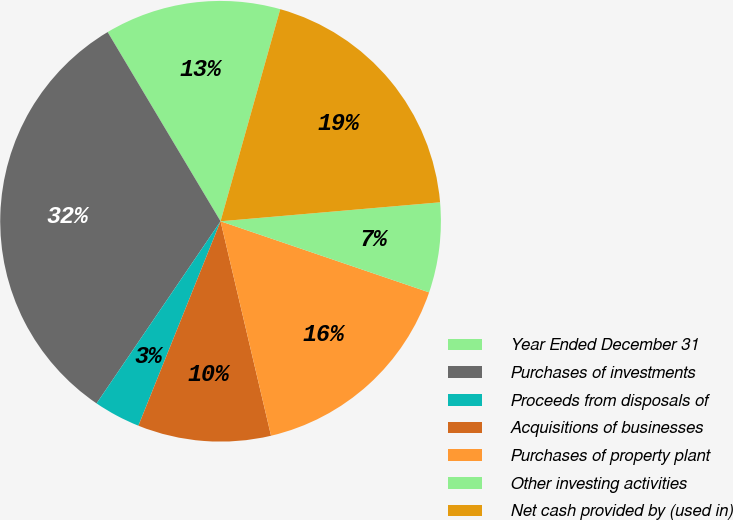Convert chart to OTSL. <chart><loc_0><loc_0><loc_500><loc_500><pie_chart><fcel>Year Ended December 31<fcel>Purchases of investments<fcel>Proceeds from disposals of<fcel>Acquisitions of businesses<fcel>Purchases of property plant<fcel>Other investing activities<fcel>Net cash provided by (used in)<nl><fcel>12.93%<fcel>31.92%<fcel>3.43%<fcel>9.76%<fcel>16.09%<fcel>6.6%<fcel>19.26%<nl></chart> 